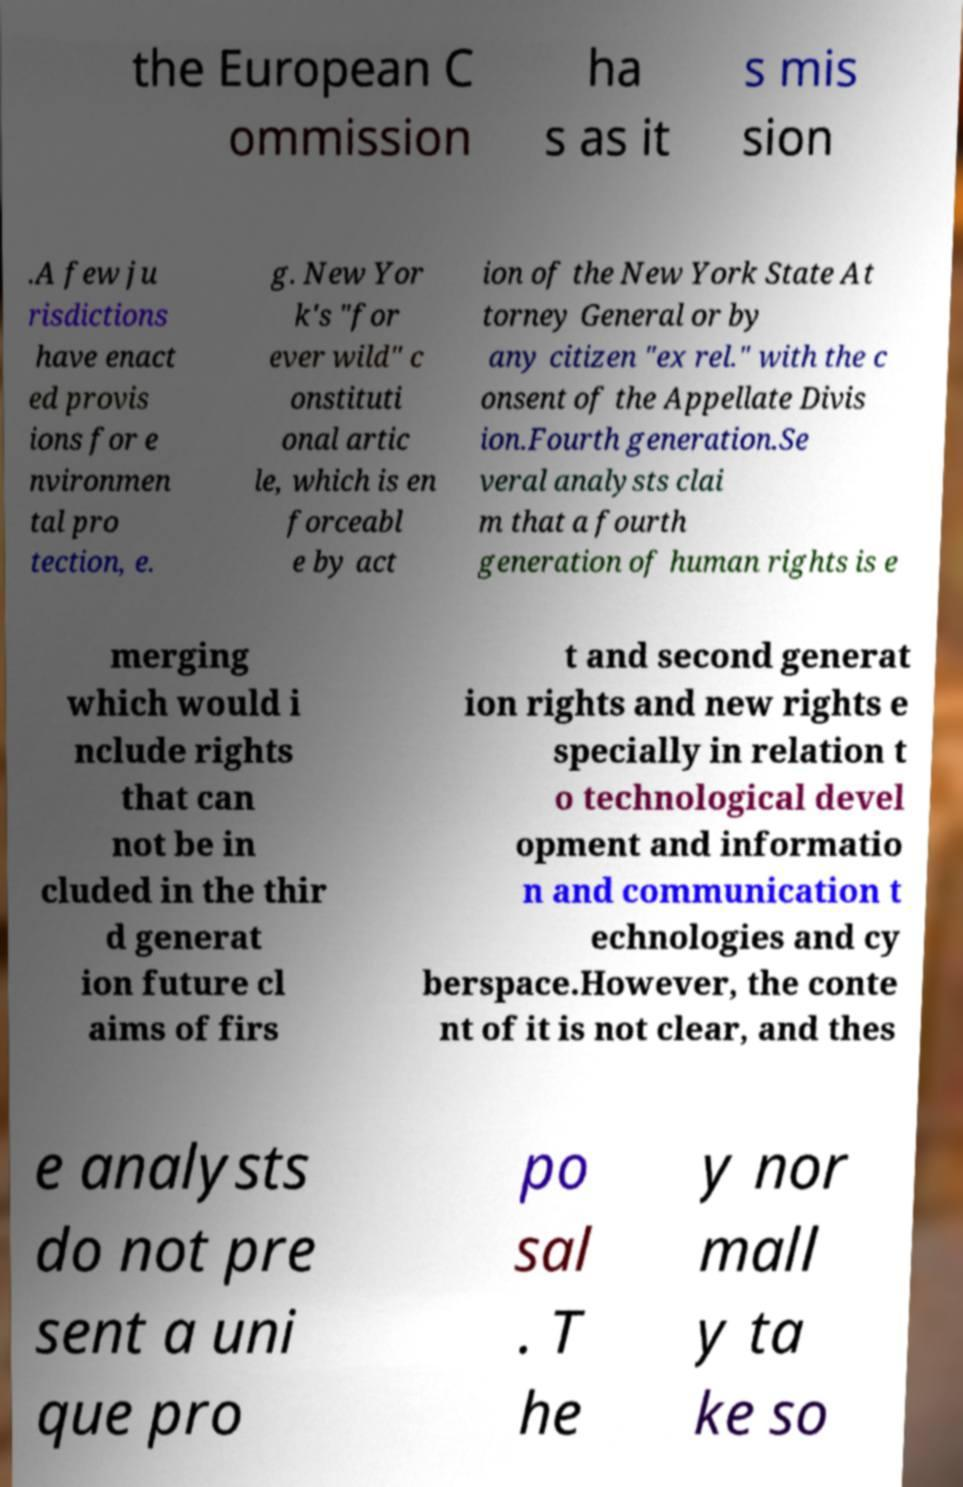Could you assist in decoding the text presented in this image and type it out clearly? the European C ommission ha s as it s mis sion .A few ju risdictions have enact ed provis ions for e nvironmen tal pro tection, e. g. New Yor k's "for ever wild" c onstituti onal artic le, which is en forceabl e by act ion of the New York State At torney General or by any citizen "ex rel." with the c onsent of the Appellate Divis ion.Fourth generation.Se veral analysts clai m that a fourth generation of human rights is e merging which would i nclude rights that can not be in cluded in the thir d generat ion future cl aims of firs t and second generat ion rights and new rights e specially in relation t o technological devel opment and informatio n and communication t echnologies and cy berspace.However, the conte nt of it is not clear, and thes e analysts do not pre sent a uni que pro po sal . T he y nor mall y ta ke so 